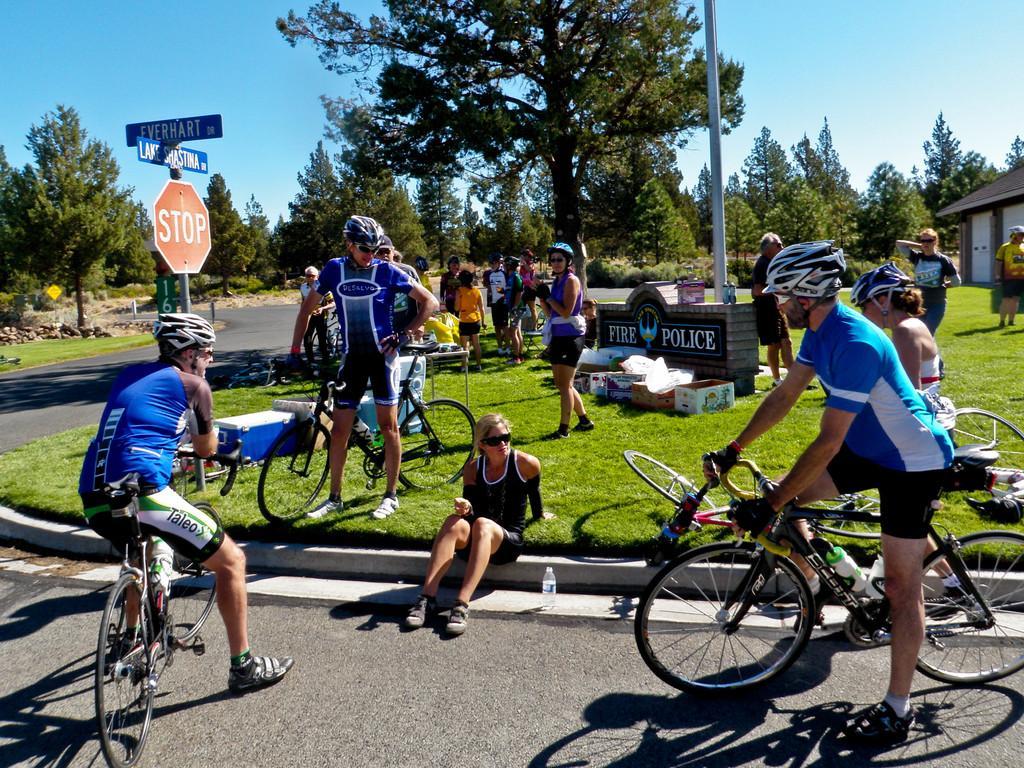Please provide a concise description of this image. Here we can see a group of people sitting and standing, some of them are holding bicycle in their hand and at the left side we can see sign board and behind them we can see trees, and the sky is clear 